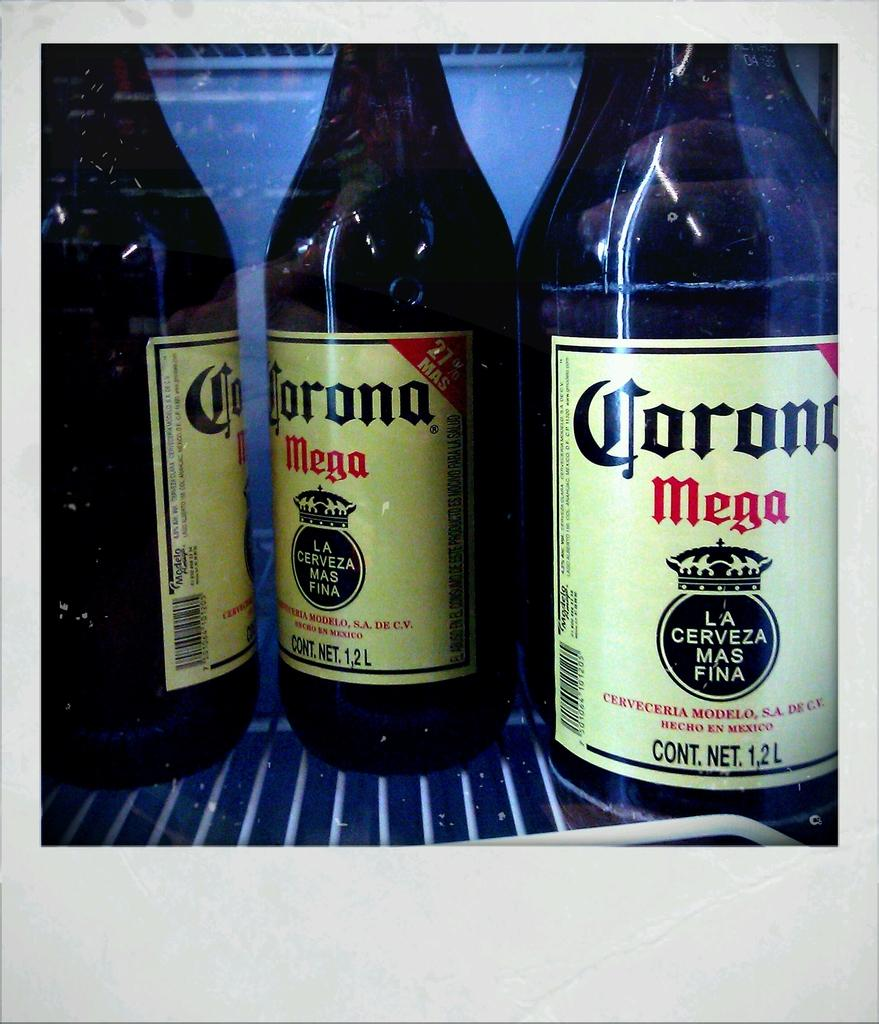<image>
Summarize the visual content of the image. Several bottles of Corona Mega on a shelf. 